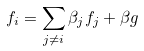<formula> <loc_0><loc_0><loc_500><loc_500>f _ { i } = \sum _ { j \not = i } \beta _ { j } f _ { j } + \beta g</formula> 